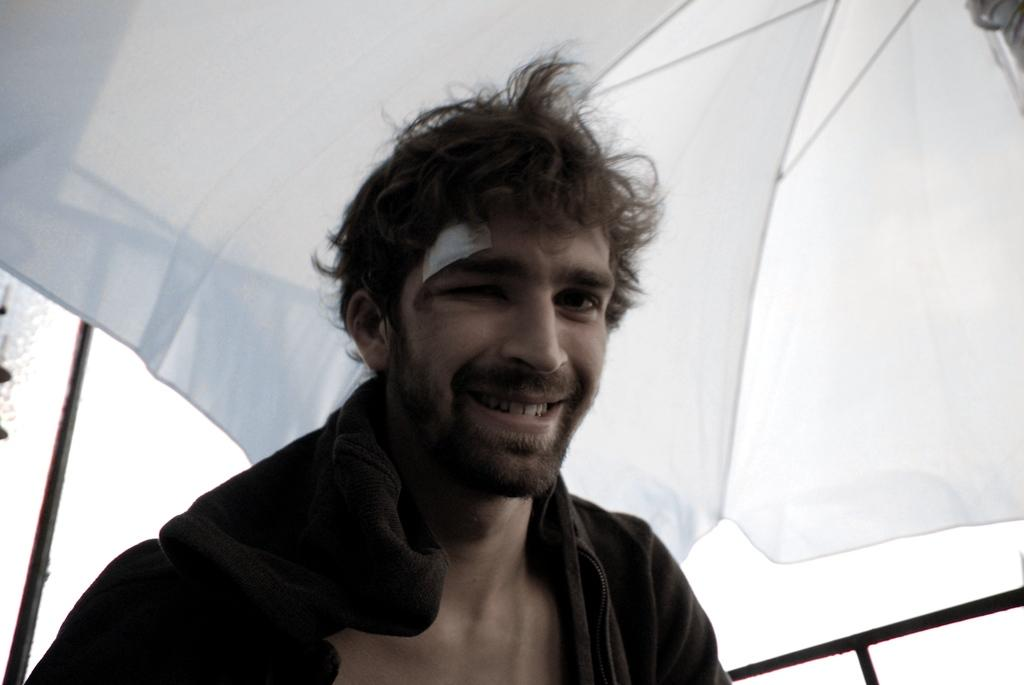Who is present in the image? There is a man in the image. What is the man doing in the image? The man is smiling in the image. What can be seen in the background of the image? There is an umbrella in the background of the image. How many mice are sitting on the man's shoulder in the image? There are no mice present in the image. What type of flight is the man taking in the image? The image does not depict a flight or any form of transportation. 